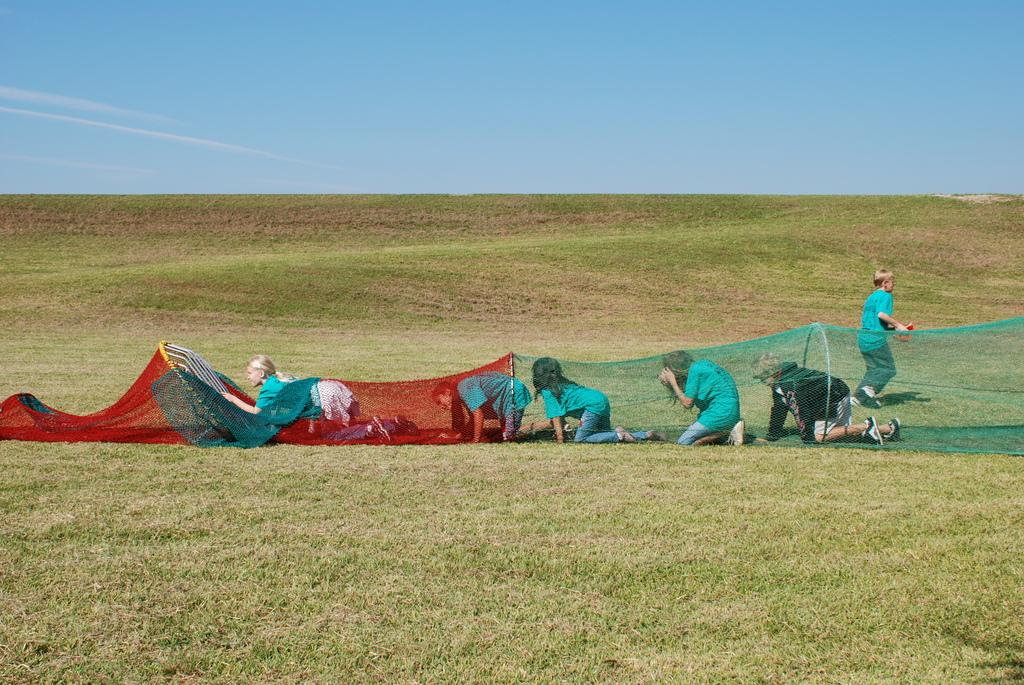What are the people in the image doing? The people are crawling inside a net in the image. What is the person on the ground doing? The person is walking on the ground in the image. What is the person holding? The person is holding an object. What type of terrain is visible in the image? There is grass visible in the image. What is visible in the background of the image? The sky is visible in the image. What type of insurance policy is being discussed by the people crawling inside the net? There is no indication in the image that the people are discussing any insurance policies. Can you hear the sound of thunder in the image? There is no sound or audio present in the image, so it is not possible to determine if there is thunder. 